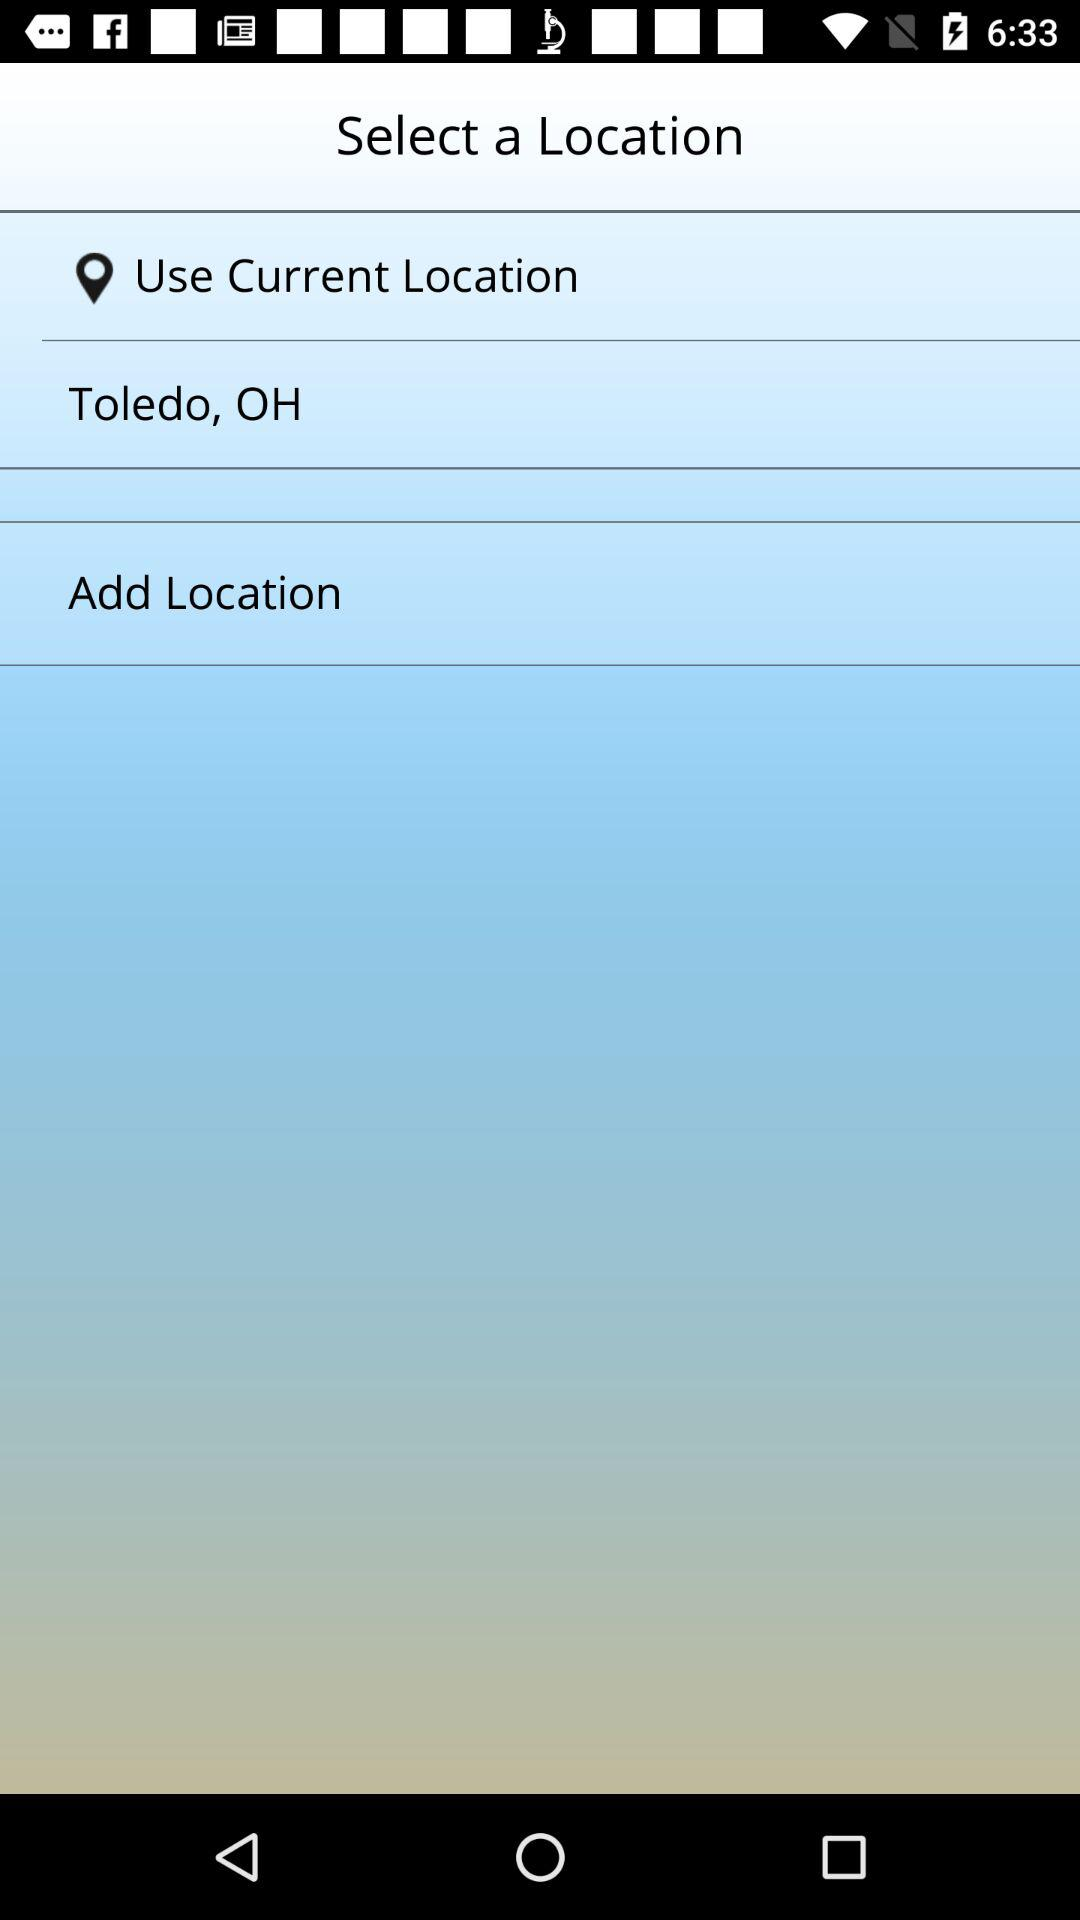What is the mentioned location? The mentioned location is Toledo, OH. 